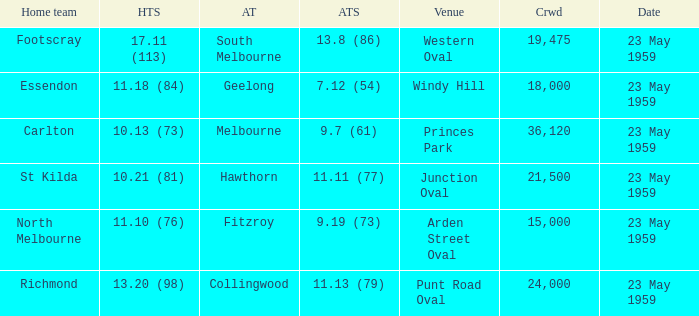What was the home team's score at the game that had a crowd larger than 24,000? 10.13 (73). 